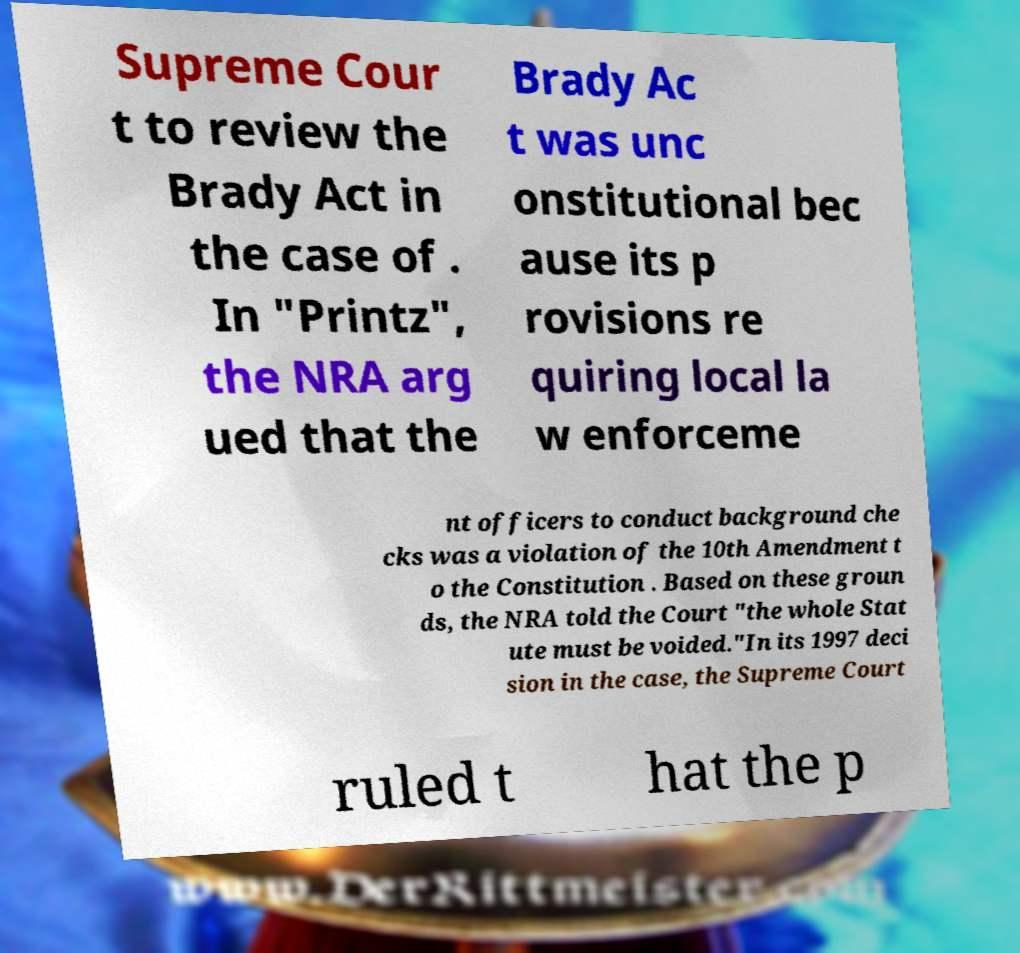What messages or text are displayed in this image? I need them in a readable, typed format. Supreme Cour t to review the Brady Act in the case of . In "Printz", the NRA arg ued that the Brady Ac t was unc onstitutional bec ause its p rovisions re quiring local la w enforceme nt officers to conduct background che cks was a violation of the 10th Amendment t o the Constitution . Based on these groun ds, the NRA told the Court "the whole Stat ute must be voided."In its 1997 deci sion in the case, the Supreme Court ruled t hat the p 